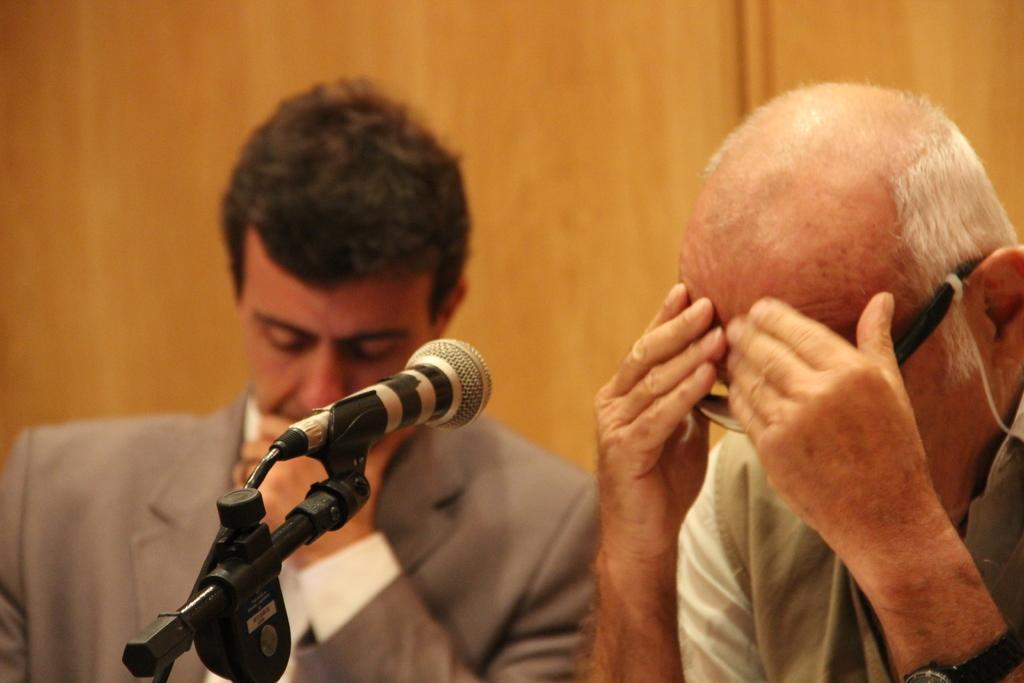Describe this image in one or two sentences. In this image, we can see two men sitting and there is a microphone. 